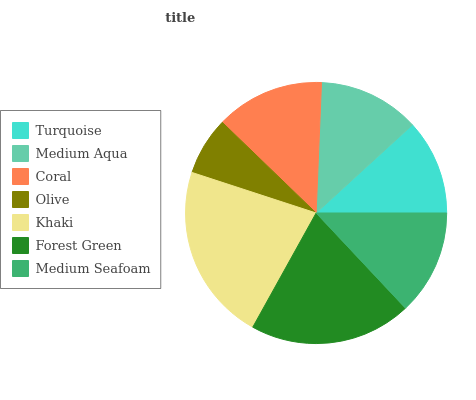Is Olive the minimum?
Answer yes or no. Yes. Is Khaki the maximum?
Answer yes or no. Yes. Is Medium Aqua the minimum?
Answer yes or no. No. Is Medium Aqua the maximum?
Answer yes or no. No. Is Medium Aqua greater than Turquoise?
Answer yes or no. Yes. Is Turquoise less than Medium Aqua?
Answer yes or no. Yes. Is Turquoise greater than Medium Aqua?
Answer yes or no. No. Is Medium Aqua less than Turquoise?
Answer yes or no. No. Is Medium Seafoam the high median?
Answer yes or no. Yes. Is Medium Seafoam the low median?
Answer yes or no. Yes. Is Forest Green the high median?
Answer yes or no. No. Is Khaki the low median?
Answer yes or no. No. 